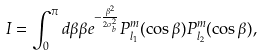Convert formula to latex. <formula><loc_0><loc_0><loc_500><loc_500>I = \int _ { 0 } ^ { \pi } d \beta \beta e ^ { - \frac { \beta ^ { 2 } } { 2 \sigma _ { b } ^ { 2 } } } P _ { l _ { 1 } } ^ { m } ( \cos \beta ) P _ { l _ { 2 } } ^ { m } ( \cos \beta ) ,</formula> 